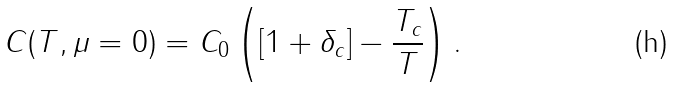Convert formula to latex. <formula><loc_0><loc_0><loc_500><loc_500>C ( T , \mu = 0 ) = C _ { 0 } \left ( [ 1 + \delta _ { c } ] - \frac { T _ { c } } { T } \right ) .</formula> 